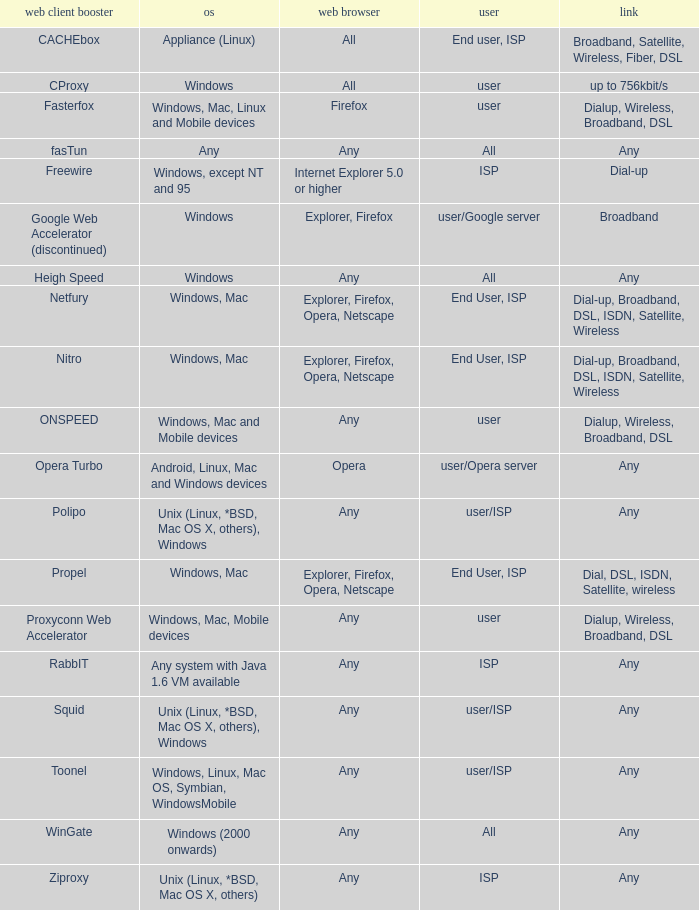What is the connection for the proxyconn web accelerator web client accelerator? Dialup, Wireless, Broadband, DSL. 